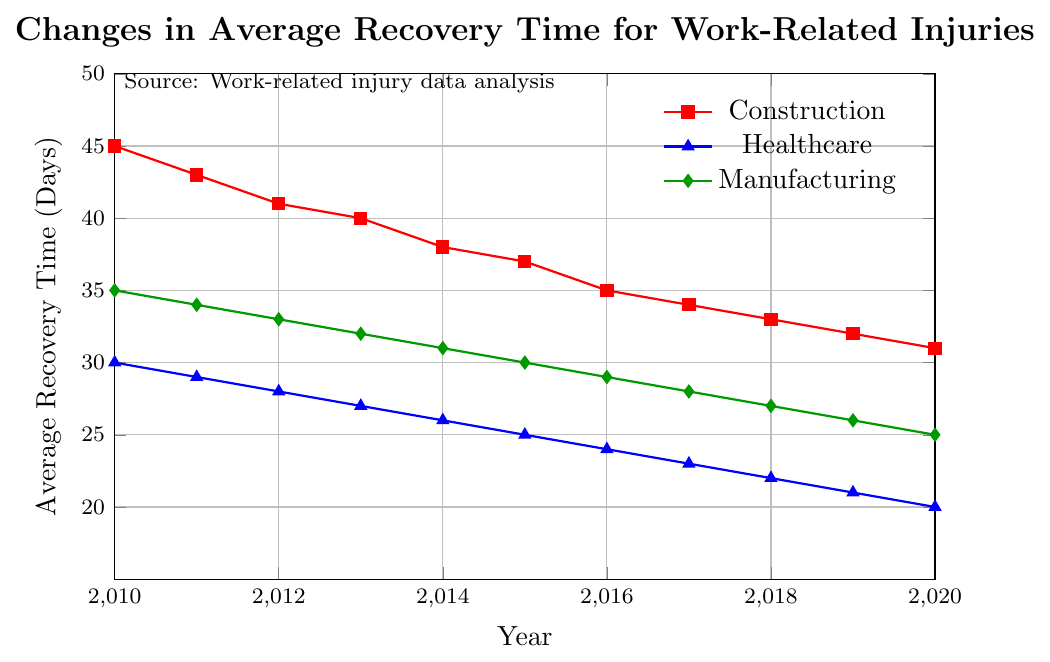What's the average recovery time in 2015 across all industries? To calculate the average recovery time in 2015, sum the recovery times from each industry and divide by the number of industries. For Construction: 37, for Healthcare: 25, and for Manufacturing: 30. Sum = 37 + 25 + 30 = 92. Average = 92 / 3 = 30.67
Answer: 30.67 By how many days did the average recovery time in the Construction industry decrease from 2010 to 2020? Subtract the average recovery time in 2020 from that in 2010 for the Construction industry. In 2010, it was 45 days, and in 2020, it was 31 days. Difference = 45 - 31 = 14
Answer: 14 Which industry had the lowest average recovery time in 2020? Compare the average recovery times in 2020: Construction = 31, Healthcare = 20, Manufacturing = 25. The lowest is Healthcare with 20 days
Answer: Healthcare How does the trend in average recovery time from 2010 to 2020 compare between Healthcare and Manufacturing industries? Examine the slopes of the lines for each industry from 2010 to 2020. Both Healthcare and Manufacturing show a consistent downward trend, but Healthcare's line is steeper, indicating a faster reduction.
Answer: Healthcare decreased faster What's the difference in average recovery time between Healthcare and Construction industries in 2018? Subtract the average recovery time for Healthcare from that for Construction in 2018. Construction = 33, Healthcare = 22. Difference: 33 - 22 = 11
Answer: 11 If the trends continue, which industry is likely to have the shortest recovery time by 2025? Given that Healthcare already has the shortest recovery time and it has the steepest downward trend, it is likely to continue having the shortest recovery time by 2025.
Answer: Healthcare What's the combined average recovery time across all industries in 2016? Sum the average recovery times for all industries in 2016 and divide by the number of industries. Construction: 35, Healthcare: 24, Manufacturing: 29. Sum = 35 + 24 + 29 = 88. Average = 88 / 3 = 29.33
Answer: 29.33 Between which years did the Construction industry see the biggest yearly drop in average recovery time? Compare the yearly changes in average recovery time for Construction. The biggest drop is between 2014 (38) and 2015 (37) with a difference of 2 days, which is the consistent difference.
Answer: 2011 to 2012 Which industry had nearly the same average recovery time in 2010 as Manufacturing in 2012? Compare the average recovery times. Manufacturing in 2012: 33. Healthcare in 2012: 28. Construction in 2012: 41. None are exactly the same, but  Healthcare is the closest with 28.
Answer: Healthcare 